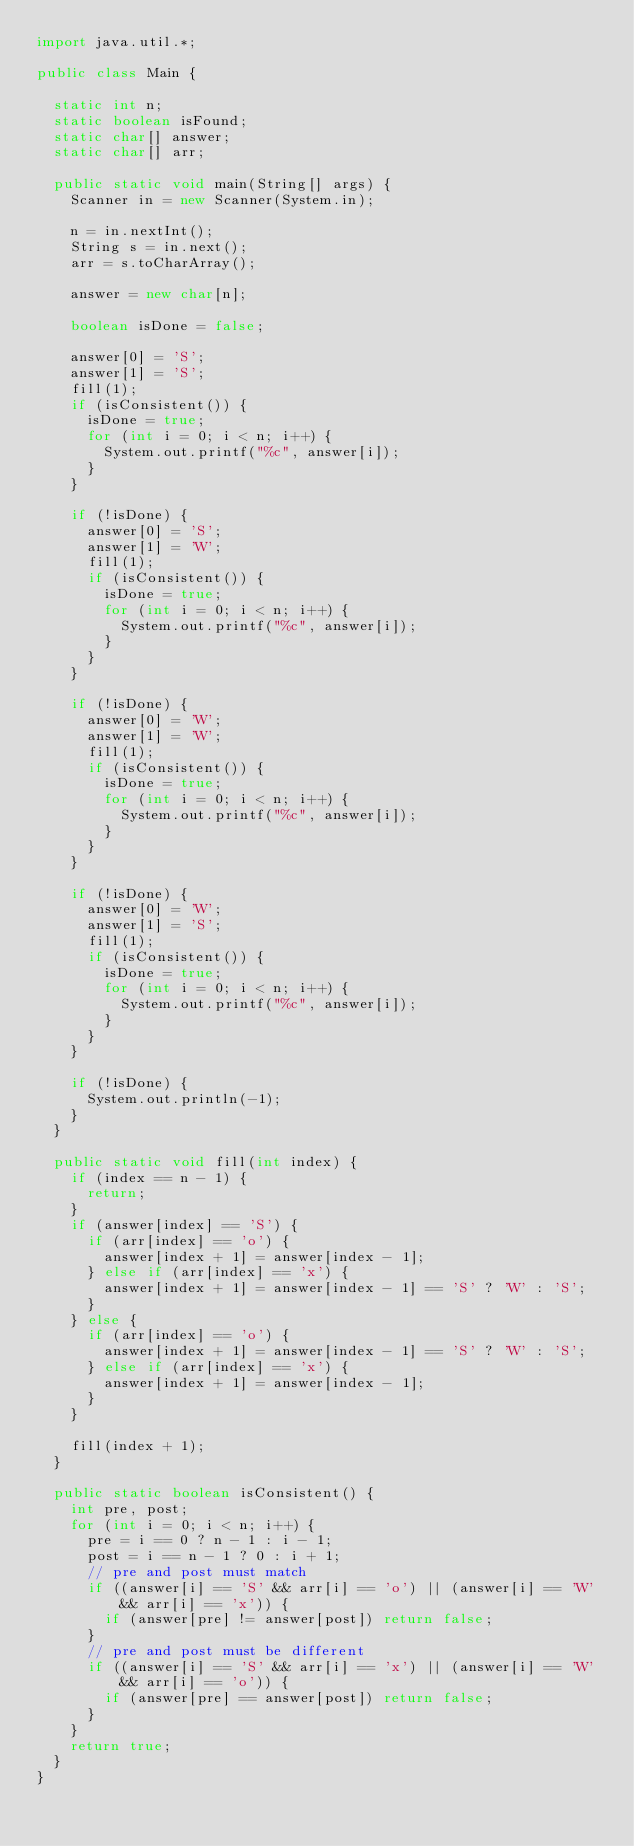Convert code to text. <code><loc_0><loc_0><loc_500><loc_500><_Java_>import java.util.*;

public class Main {

	static int n;
	static boolean isFound;
	static char[] answer;
	static char[] arr;
	
	public static void main(String[] args) {
		Scanner in = new Scanner(System.in);
		
		n = in.nextInt();
		String s = in.next();
		arr = s.toCharArray();
		
		answer = new char[n];
		
		boolean isDone = false;
		
		answer[0] = 'S';
		answer[1] = 'S';
		fill(1);
		if (isConsistent()) {
			isDone = true;
			for (int i = 0; i < n; i++) {
				System.out.printf("%c", answer[i]);
			}
		}
		
		if (!isDone) {
			answer[0] = 'S';
			answer[1] = 'W';
			fill(1);
			if (isConsistent()) {
				isDone = true;
				for (int i = 0; i < n; i++) {
					System.out.printf("%c", answer[i]);
				}
			}
		}
		
		if (!isDone) {
			answer[0] = 'W';
			answer[1] = 'W';
			fill(1);
			if (isConsistent()) {
				isDone = true;
				for (int i = 0; i < n; i++) {
					System.out.printf("%c", answer[i]);
				}
			}
		}

		if (!isDone) {
			answer[0] = 'W';
			answer[1] = 'S';
			fill(1);
			if (isConsistent()) {
				isDone = true;
				for (int i = 0; i < n; i++) {
					System.out.printf("%c", answer[i]);
				}
			}
		}
		
		if (!isDone) {
			System.out.println(-1);
		}
	}
	
	public static void fill(int index) {
		if (index == n - 1) {
			return;
		}
		if (answer[index] == 'S') {
			if (arr[index] == 'o') {
				answer[index + 1] = answer[index - 1];
			} else if (arr[index] == 'x') {
				answer[index + 1] = answer[index - 1] == 'S' ? 'W' : 'S';
			}
		} else {
			if (arr[index] == 'o') {
				answer[index + 1] = answer[index - 1] == 'S' ? 'W' : 'S';
			} else if (arr[index] == 'x') {
				answer[index + 1] = answer[index - 1];
			}
		}
		
		fill(index + 1);
	}
	
	public static boolean isConsistent() {
		int pre, post;
		for (int i = 0; i < n; i++) {
			pre = i == 0 ? n - 1 : i - 1;
			post = i == n - 1 ? 0 : i + 1;
			// pre and post must match
			if ((answer[i] == 'S' && arr[i] == 'o') || (answer[i] == 'W' && arr[i] == 'x')) {
				if (answer[pre] != answer[post]) return false;
			}
			// pre and post must be different
			if ((answer[i] == 'S' && arr[i] == 'x') || (answer[i] == 'W' && arr[i] == 'o')) {
				if (answer[pre] == answer[post]) return false;
			}
		}
		return true;
	}
}</code> 